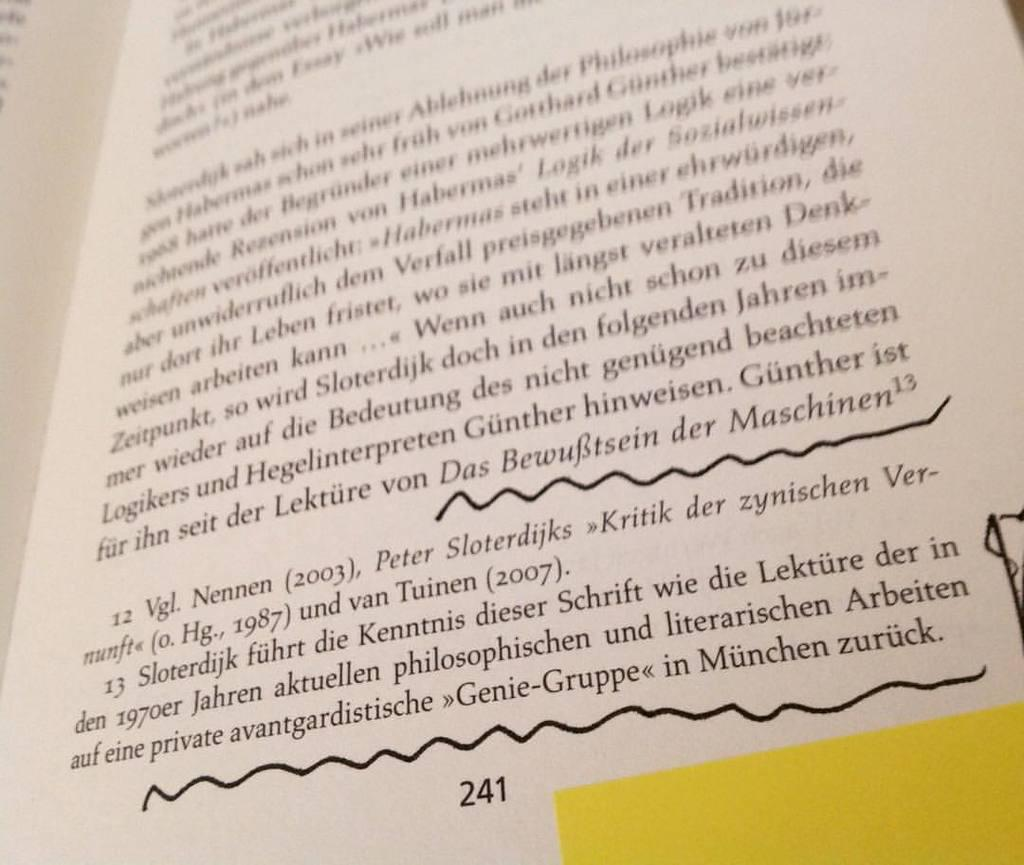Provide a one-sentence caption for the provided image. Open book with writing on it on page 241. 